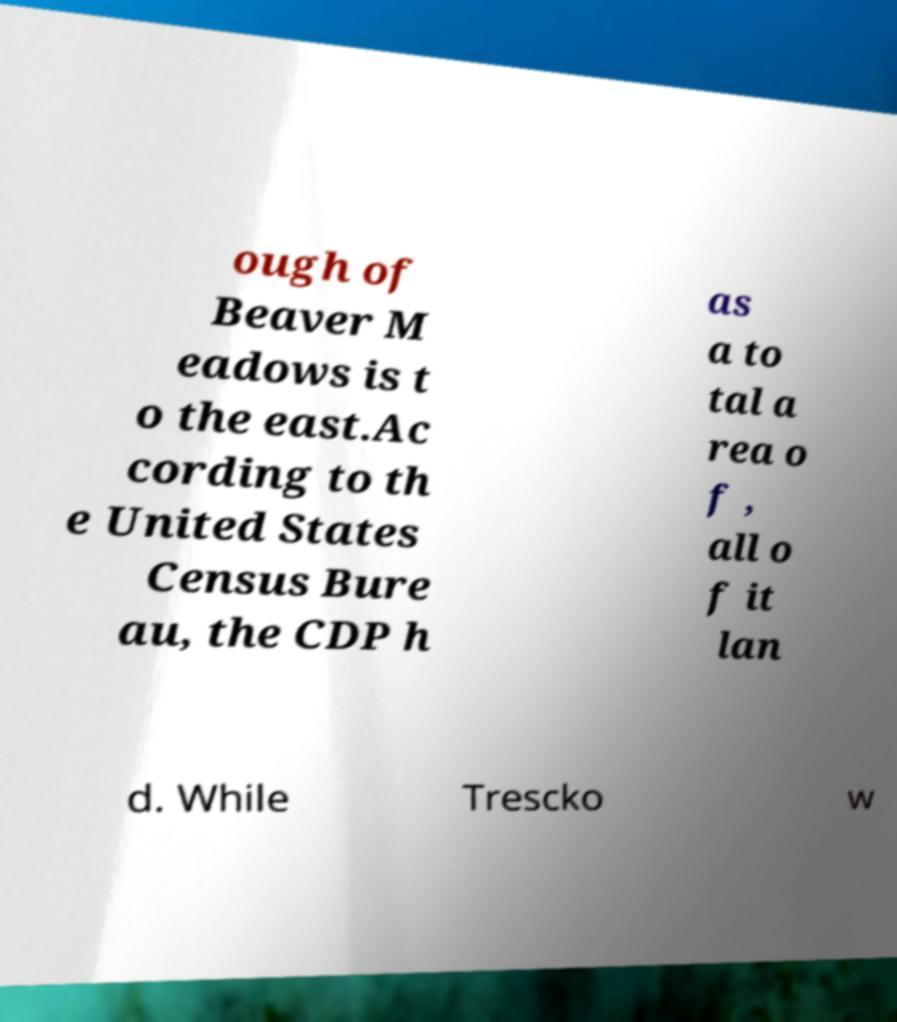What messages or text are displayed in this image? I need them in a readable, typed format. ough of Beaver M eadows is t o the east.Ac cording to th e United States Census Bure au, the CDP h as a to tal a rea o f , all o f it lan d. While Trescko w 